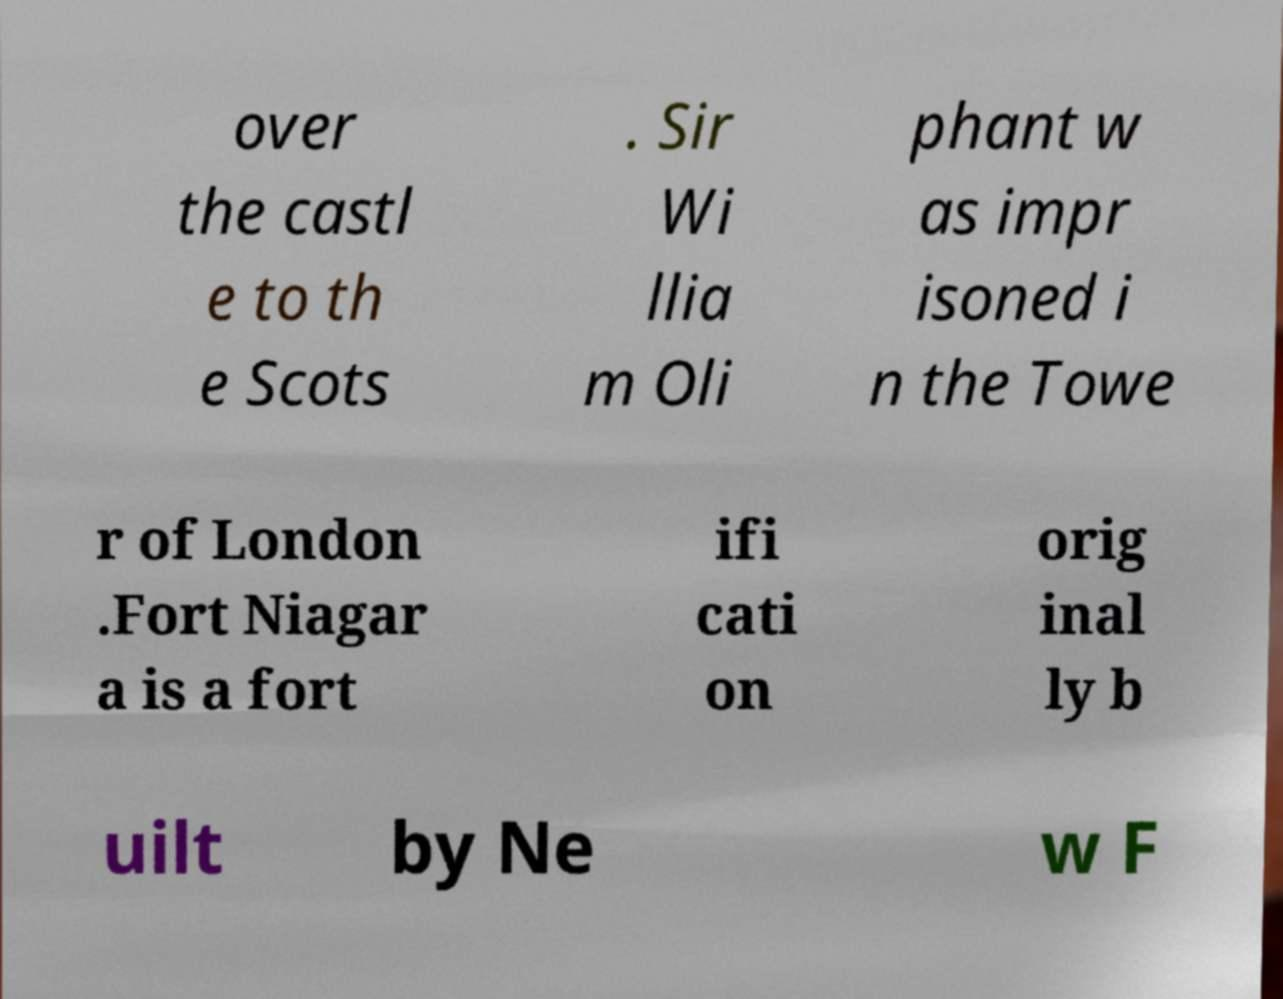Please identify and transcribe the text found in this image. over the castl e to th e Scots . Sir Wi llia m Oli phant w as impr isoned i n the Towe r of London .Fort Niagar a is a fort ifi cati on orig inal ly b uilt by Ne w F 